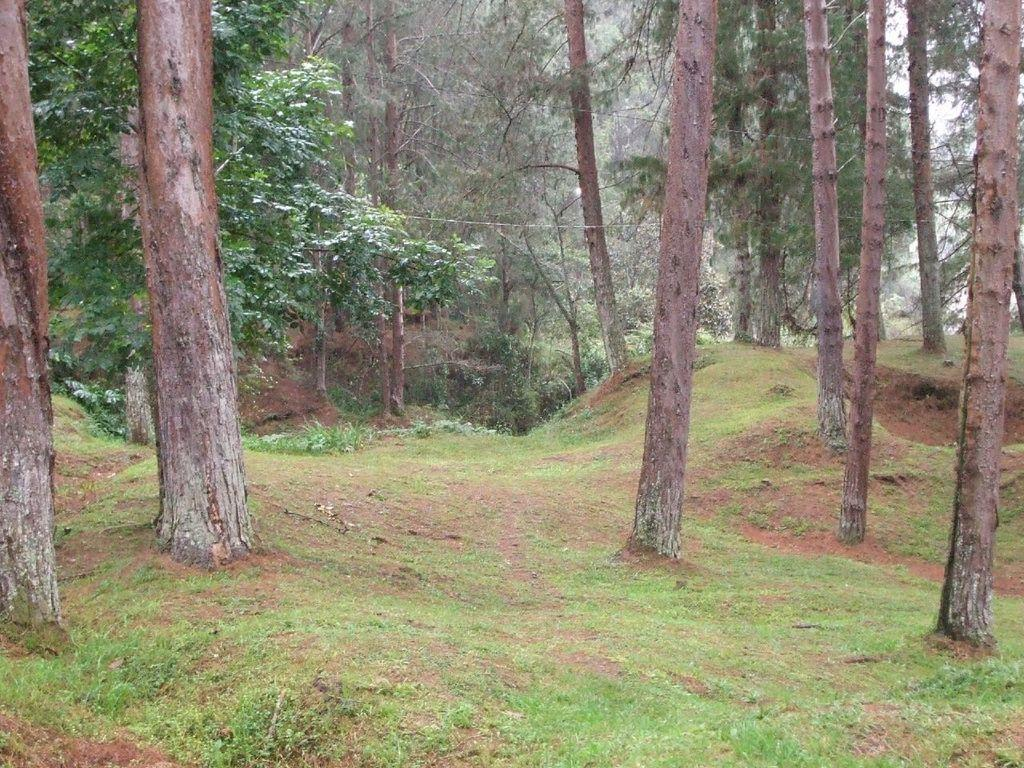What type of environment is depicted in the image? The image is an outside view. What type of vegetation is present on the ground in the image? There is grass on the ground in the image. What can be seen in the background of the image? There are many trees in the background of the image. What type of pie is being served on the stage in the image? There is no pie or stage present in the image; it is an outside view with grass and trees. 